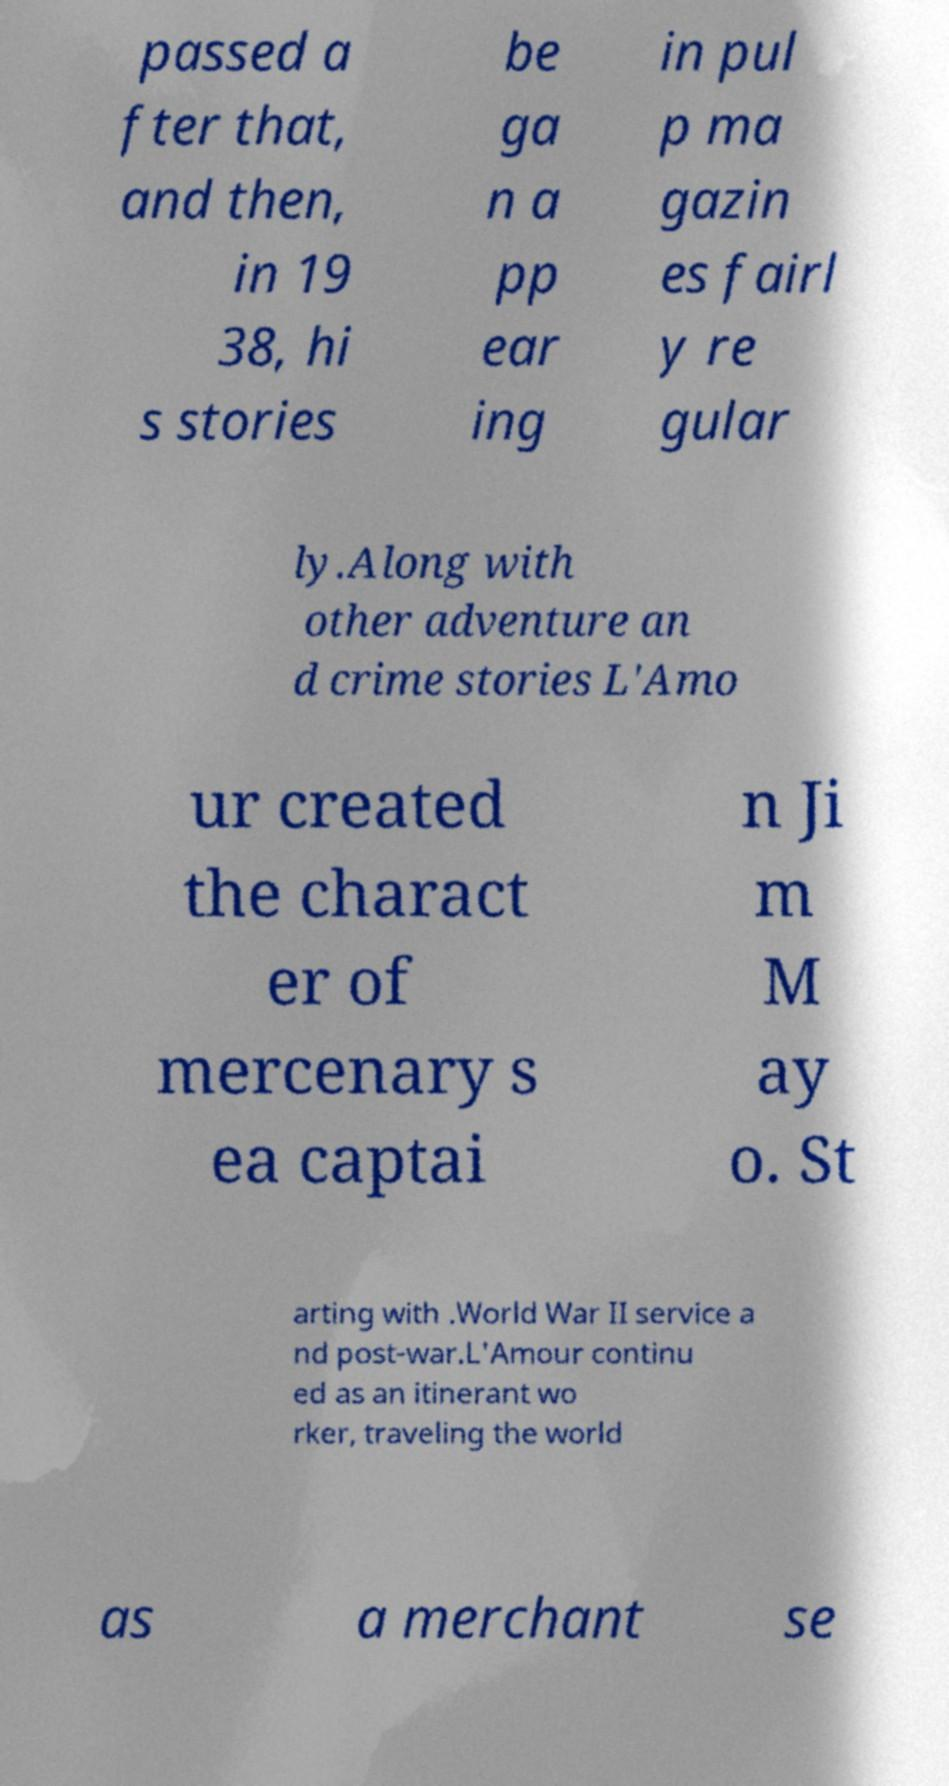I need the written content from this picture converted into text. Can you do that? passed a fter that, and then, in 19 38, hi s stories be ga n a pp ear ing in pul p ma gazin es fairl y re gular ly.Along with other adventure an d crime stories L'Amo ur created the charact er of mercenary s ea captai n Ji m M ay o. St arting with .World War II service a nd post-war.L'Amour continu ed as an itinerant wo rker, traveling the world as a merchant se 